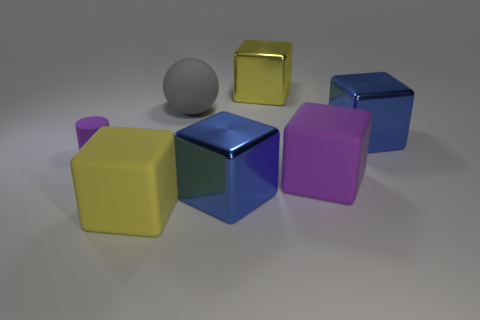Subtract all yellow matte blocks. How many blocks are left? 4 Subtract 1 cubes. How many cubes are left? 4 Subtract all blue blocks. How many blocks are left? 3 Subtract all blocks. How many objects are left? 2 Add 1 big yellow objects. How many objects exist? 8 Add 5 metal blocks. How many metal blocks exist? 8 Subtract 0 red spheres. How many objects are left? 7 Subtract all brown blocks. Subtract all brown cylinders. How many blocks are left? 5 Subtract all cyan balls. How many purple cubes are left? 1 Subtract all big metal things. Subtract all large gray cylinders. How many objects are left? 4 